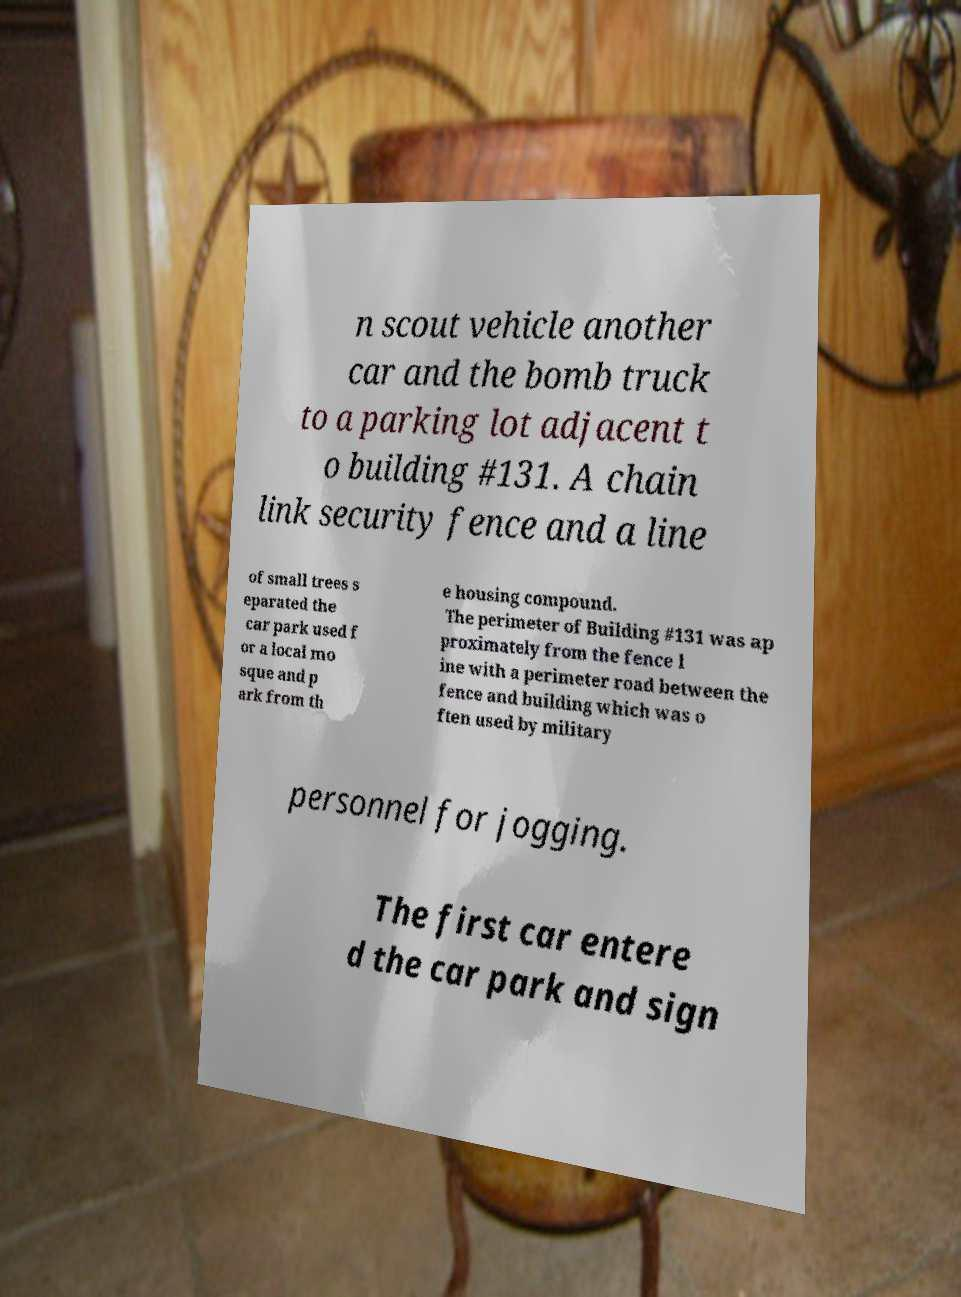Could you extract and type out the text from this image? n scout vehicle another car and the bomb truck to a parking lot adjacent t o building #131. A chain link security fence and a line of small trees s eparated the car park used f or a local mo sque and p ark from th e housing compound. The perimeter of Building #131 was ap proximately from the fence l ine with a perimeter road between the fence and building which was o ften used by military personnel for jogging. The first car entere d the car park and sign 